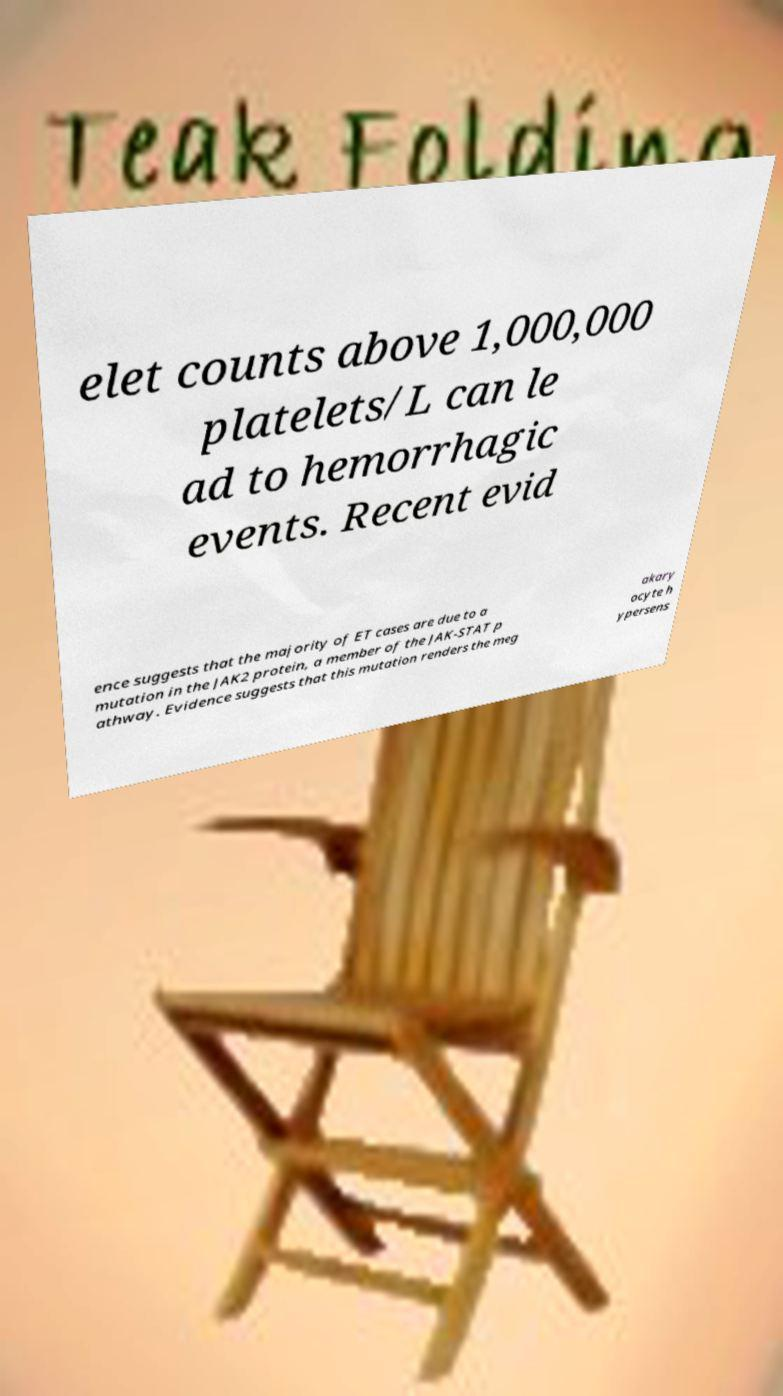For documentation purposes, I need the text within this image transcribed. Could you provide that? elet counts above 1,000,000 platelets/L can le ad to hemorrhagic events. Recent evid ence suggests that the majority of ET cases are due to a mutation in the JAK2 protein, a member of the JAK-STAT p athway. Evidence suggests that this mutation renders the meg akary ocyte h ypersens 